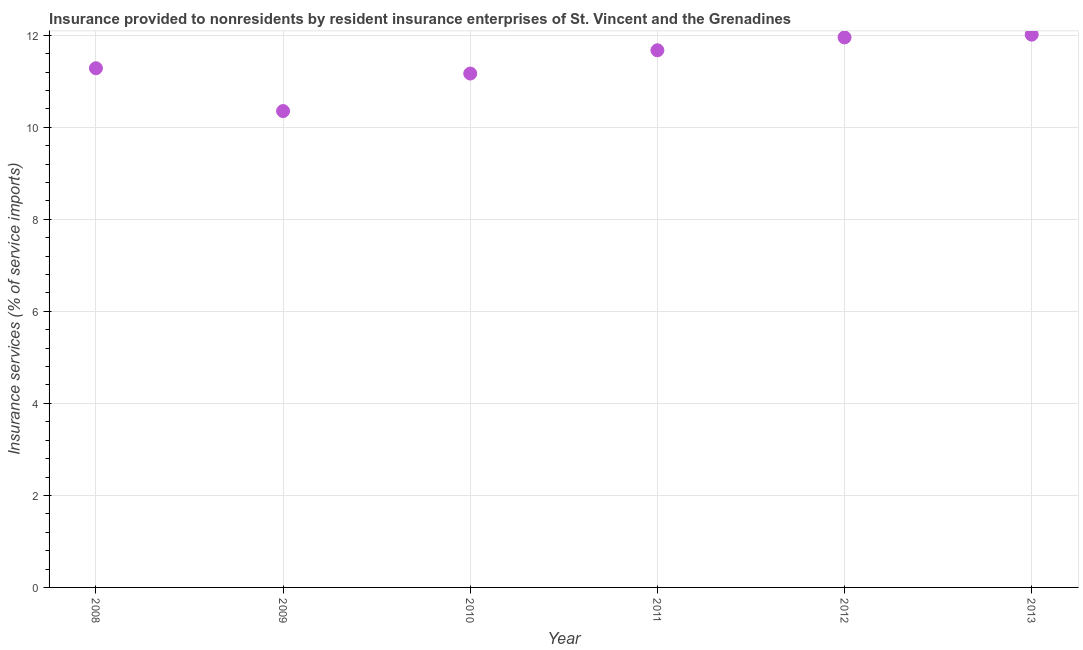What is the insurance and financial services in 2009?
Provide a short and direct response. 10.35. Across all years, what is the maximum insurance and financial services?
Ensure brevity in your answer.  12.01. Across all years, what is the minimum insurance and financial services?
Provide a succinct answer. 10.35. In which year was the insurance and financial services maximum?
Ensure brevity in your answer.  2013. What is the sum of the insurance and financial services?
Provide a short and direct response. 68.45. What is the difference between the insurance and financial services in 2008 and 2010?
Your answer should be very brief. 0.12. What is the average insurance and financial services per year?
Offer a very short reply. 11.41. What is the median insurance and financial services?
Give a very brief answer. 11.48. What is the ratio of the insurance and financial services in 2009 to that in 2011?
Provide a succinct answer. 0.89. Is the insurance and financial services in 2009 less than that in 2012?
Your answer should be very brief. Yes. What is the difference between the highest and the second highest insurance and financial services?
Your answer should be compact. 0.06. What is the difference between the highest and the lowest insurance and financial services?
Provide a succinct answer. 1.66. Does the insurance and financial services monotonically increase over the years?
Offer a very short reply. No. How many years are there in the graph?
Provide a succinct answer. 6. What is the difference between two consecutive major ticks on the Y-axis?
Ensure brevity in your answer.  2. Does the graph contain grids?
Your answer should be compact. Yes. What is the title of the graph?
Provide a succinct answer. Insurance provided to nonresidents by resident insurance enterprises of St. Vincent and the Grenadines. What is the label or title of the Y-axis?
Ensure brevity in your answer.  Insurance services (% of service imports). What is the Insurance services (% of service imports) in 2008?
Offer a very short reply. 11.28. What is the Insurance services (% of service imports) in 2009?
Your response must be concise. 10.35. What is the Insurance services (% of service imports) in 2010?
Your response must be concise. 11.17. What is the Insurance services (% of service imports) in 2011?
Give a very brief answer. 11.68. What is the Insurance services (% of service imports) in 2012?
Offer a very short reply. 11.95. What is the Insurance services (% of service imports) in 2013?
Provide a succinct answer. 12.01. What is the difference between the Insurance services (% of service imports) in 2008 and 2009?
Ensure brevity in your answer.  0.93. What is the difference between the Insurance services (% of service imports) in 2008 and 2010?
Your answer should be very brief. 0.12. What is the difference between the Insurance services (% of service imports) in 2008 and 2011?
Offer a very short reply. -0.39. What is the difference between the Insurance services (% of service imports) in 2008 and 2012?
Your answer should be compact. -0.67. What is the difference between the Insurance services (% of service imports) in 2008 and 2013?
Your answer should be compact. -0.73. What is the difference between the Insurance services (% of service imports) in 2009 and 2010?
Offer a terse response. -0.82. What is the difference between the Insurance services (% of service imports) in 2009 and 2011?
Offer a very short reply. -1.32. What is the difference between the Insurance services (% of service imports) in 2009 and 2012?
Make the answer very short. -1.6. What is the difference between the Insurance services (% of service imports) in 2009 and 2013?
Your answer should be very brief. -1.66. What is the difference between the Insurance services (% of service imports) in 2010 and 2011?
Offer a very short reply. -0.51. What is the difference between the Insurance services (% of service imports) in 2010 and 2012?
Your response must be concise. -0.79. What is the difference between the Insurance services (% of service imports) in 2010 and 2013?
Provide a succinct answer. -0.85. What is the difference between the Insurance services (% of service imports) in 2011 and 2012?
Offer a very short reply. -0.28. What is the difference between the Insurance services (% of service imports) in 2011 and 2013?
Your answer should be very brief. -0.34. What is the difference between the Insurance services (% of service imports) in 2012 and 2013?
Your answer should be very brief. -0.06. What is the ratio of the Insurance services (% of service imports) in 2008 to that in 2009?
Give a very brief answer. 1.09. What is the ratio of the Insurance services (% of service imports) in 2008 to that in 2010?
Provide a short and direct response. 1.01. What is the ratio of the Insurance services (% of service imports) in 2008 to that in 2012?
Give a very brief answer. 0.94. What is the ratio of the Insurance services (% of service imports) in 2008 to that in 2013?
Offer a terse response. 0.94. What is the ratio of the Insurance services (% of service imports) in 2009 to that in 2010?
Give a very brief answer. 0.93. What is the ratio of the Insurance services (% of service imports) in 2009 to that in 2011?
Keep it short and to the point. 0.89. What is the ratio of the Insurance services (% of service imports) in 2009 to that in 2012?
Make the answer very short. 0.87. What is the ratio of the Insurance services (% of service imports) in 2009 to that in 2013?
Keep it short and to the point. 0.86. What is the ratio of the Insurance services (% of service imports) in 2010 to that in 2011?
Give a very brief answer. 0.96. What is the ratio of the Insurance services (% of service imports) in 2010 to that in 2012?
Your answer should be very brief. 0.93. What is the ratio of the Insurance services (% of service imports) in 2010 to that in 2013?
Ensure brevity in your answer.  0.93. What is the ratio of the Insurance services (% of service imports) in 2011 to that in 2012?
Provide a short and direct response. 0.98. What is the ratio of the Insurance services (% of service imports) in 2012 to that in 2013?
Ensure brevity in your answer.  0.99. 